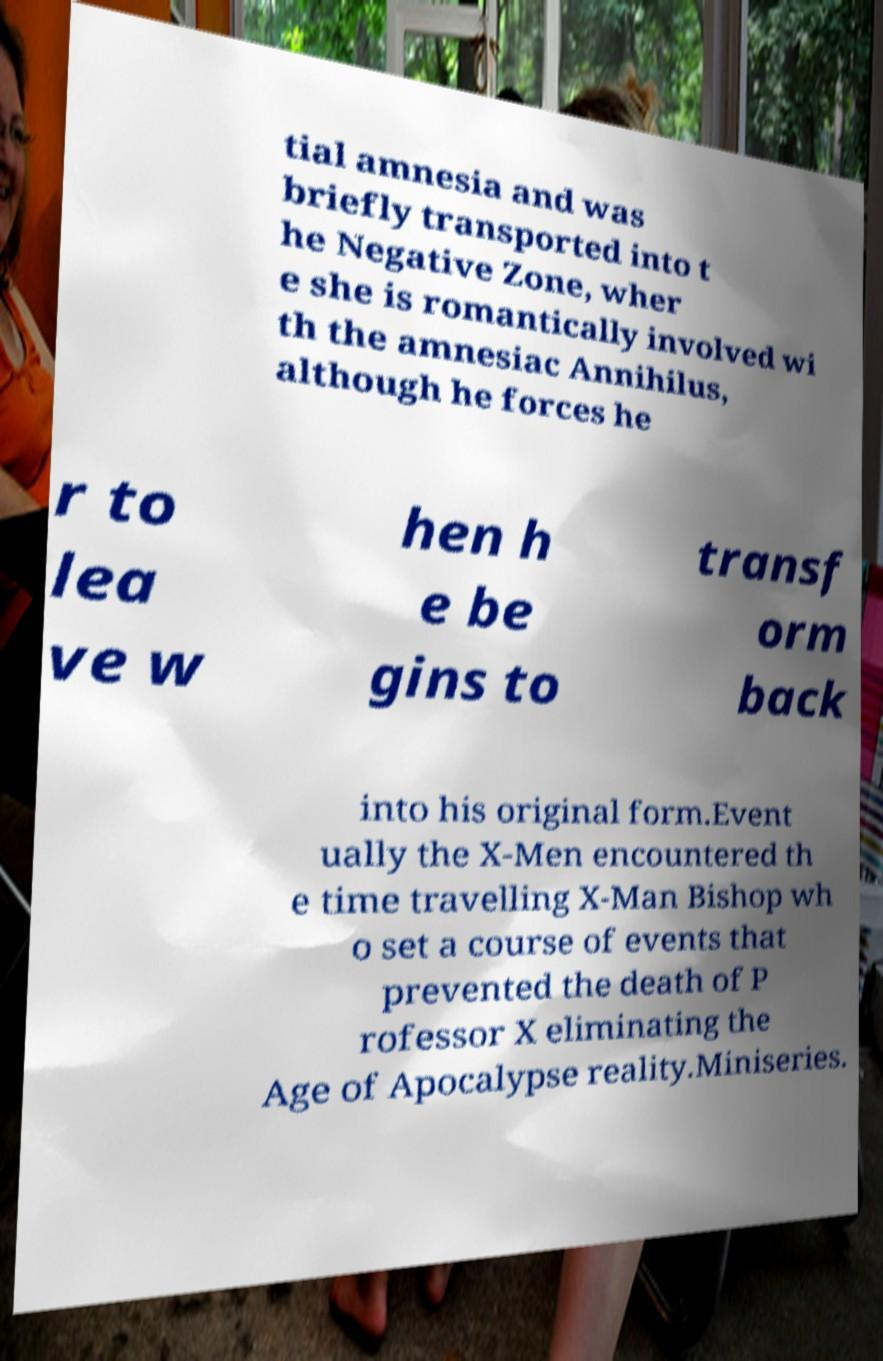For documentation purposes, I need the text within this image transcribed. Could you provide that? tial amnesia and was briefly transported into t he Negative Zone, wher e she is romantically involved wi th the amnesiac Annihilus, although he forces he r to lea ve w hen h e be gins to transf orm back into his original form.Event ually the X-Men encountered th e time travelling X-Man Bishop wh o set a course of events that prevented the death of P rofessor X eliminating the Age of Apocalypse reality.Miniseries. 